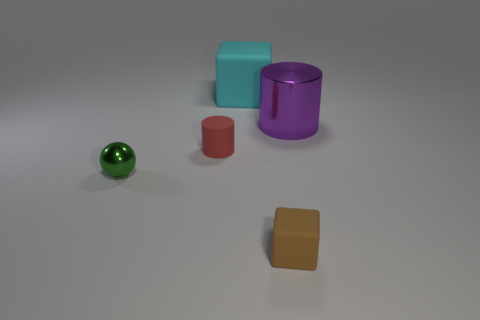Add 2 big cylinders. How many objects exist? 7 Subtract all cylinders. How many objects are left? 3 Add 1 tiny green rubber spheres. How many tiny green rubber spheres exist? 1 Subtract 0 gray cylinders. How many objects are left? 5 Subtract all brown matte blocks. Subtract all tiny green metal objects. How many objects are left? 3 Add 2 tiny green balls. How many tiny green balls are left? 3 